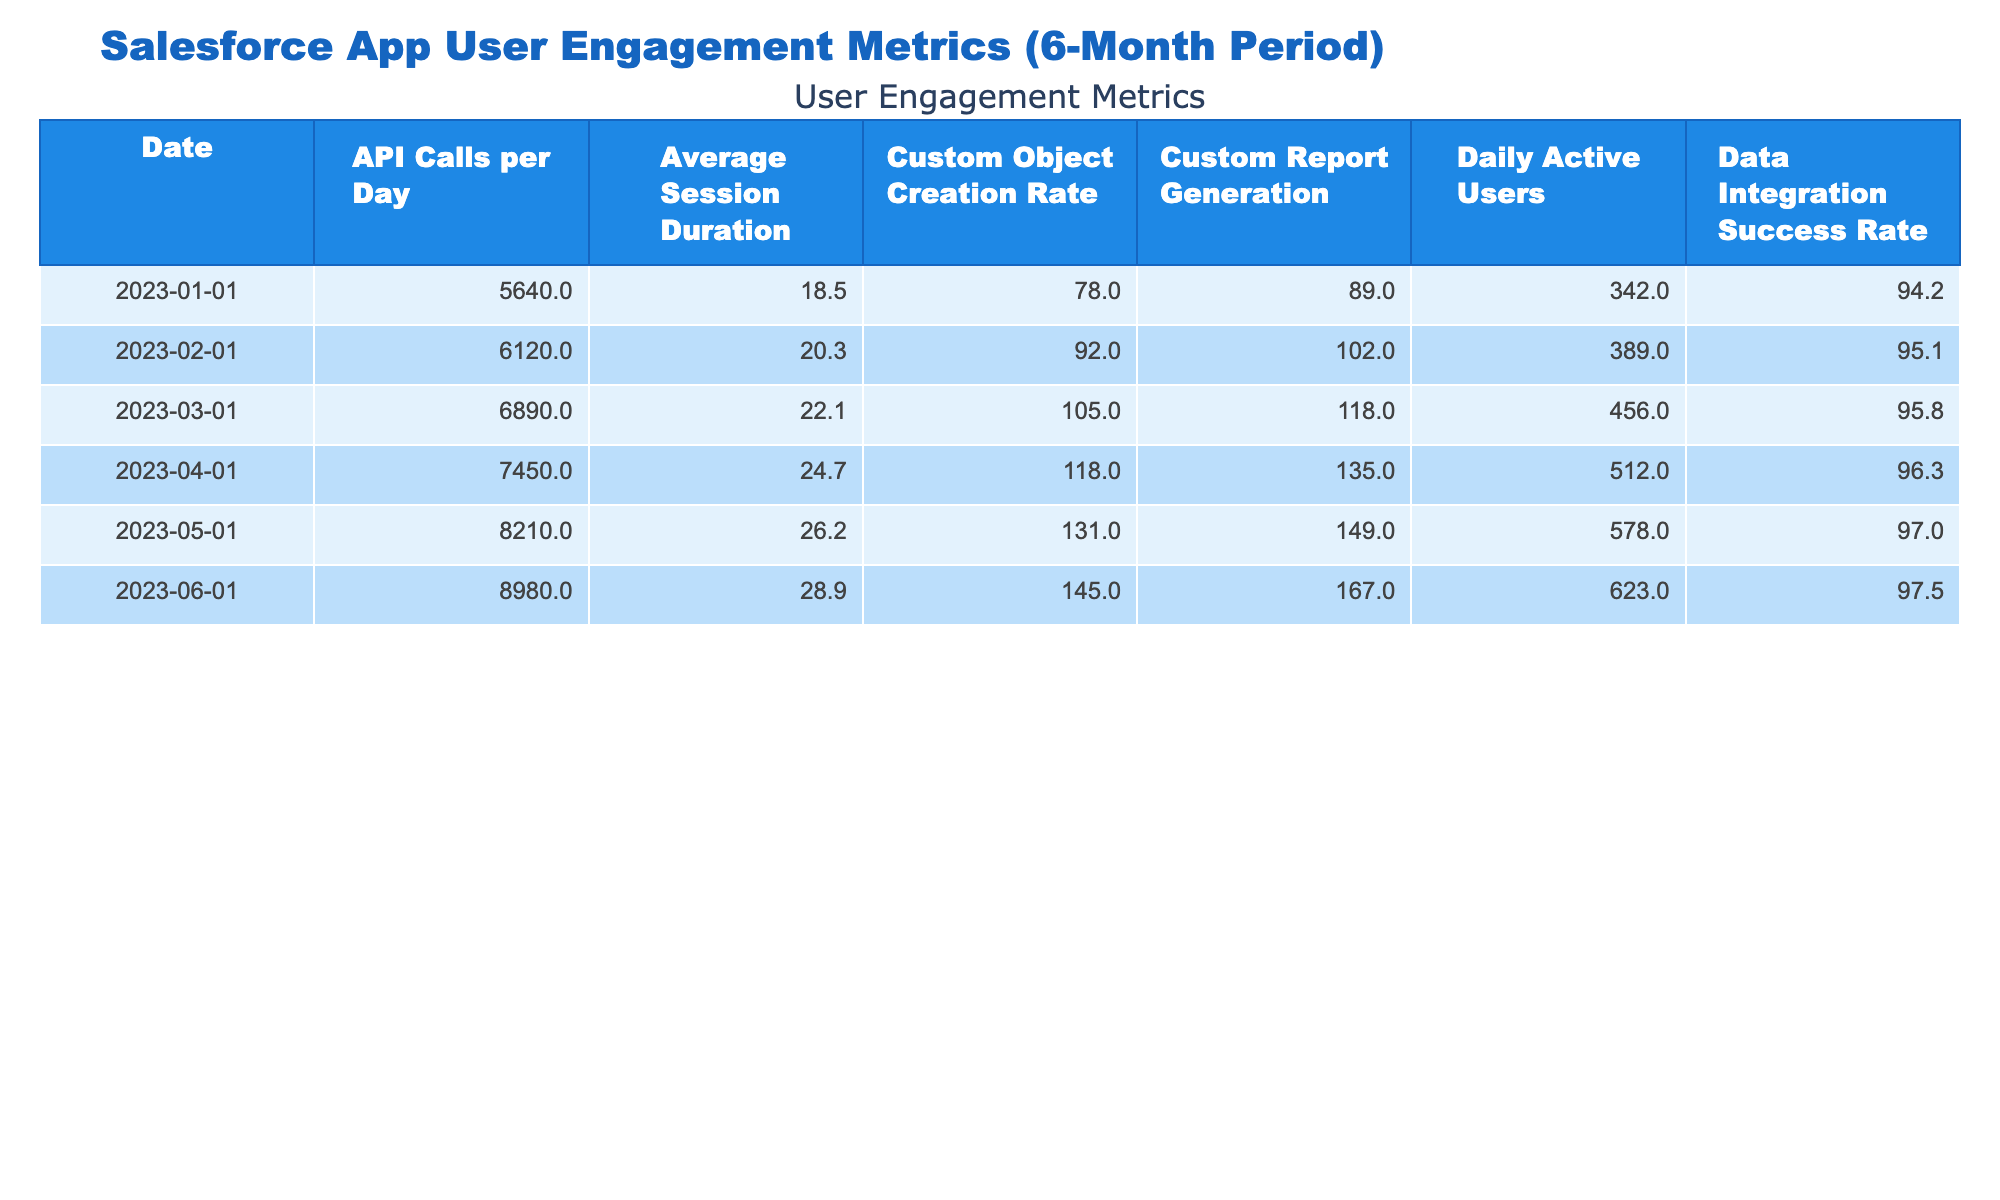What was the highest Daily Active Users recorded during the 6-month period? Looking at the "Daily Active Users" row, the values are 342, 389, 456, 512, 578, and 623. The highest value is 623, recorded on June 1, 2023.
Answer: 623 What is the Average Session Duration for May 2023? Referring to the "Average Session Duration" row for May, the value is 26.2 minutes.
Answer: 26.2 What was the rate of Custom Object Creation on March 1, 2023? The "Custom Object Creation Rate" for March 2023 is directly available in the table, which shows a value of 105.
Answer: 105 Did the Data Integration Success Rate improve from January to June 2023? By comparing the "Data Integration Success Rate" values of 94.2 in January and 97.5 in June, we can see that the values increased.
Answer: Yes What was the total number of API Calls made in April and May 2023? To find the total, we add the API Calls for April (7450) and May (8210) together: 7450 + 8210 = 15660.
Answer: 15660 What is the average Custom Report Generation over the 6 months? The values for Custom Report Generation are 89, 102, 118, 135, 149, and 167. Adding these gives 860, and dividing by 6 (the number of months) results in an average of approximately 143.33.
Answer: 143.33 What was the increase in Daily Active Users from January to April 2023? The Daily Active Users in January was 342, and in April it was 512. The increase is 512 - 342 = 170.
Answer: 170 Which month had the lowest Custom Object Creation Rate, and what was the value? The "Custom Object Creation Rate" for January is 78, which is less than all other months. January is therefore the month with the lowest rate.
Answer: January: 78 How much did the Average Session Duration increase from February to June 2023? The Average Session Duration in February was 20.3, and in June it was 28.9. The increase is 28.9 - 20.3 = 8.6 minutes.
Answer: 8.6 Was the API Calls per Day higher in June than in January? The API Calls per Day values are 5640 in January and 8980 in June. Since 8980 is greater than 5640, the answer is yes.
Answer: Yes 